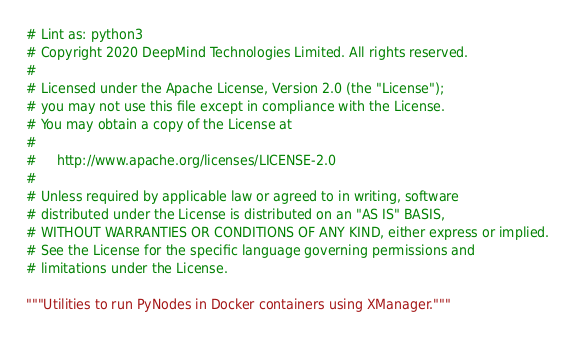<code> <loc_0><loc_0><loc_500><loc_500><_Python_># Lint as: python3
# Copyright 2020 DeepMind Technologies Limited. All rights reserved.
#
# Licensed under the Apache License, Version 2.0 (the "License");
# you may not use this file except in compliance with the License.
# You may obtain a copy of the License at
#
#     http://www.apache.org/licenses/LICENSE-2.0
#
# Unless required by applicable law or agreed to in writing, software
# distributed under the License is distributed on an "AS IS" BASIS,
# WITHOUT WARRANTIES OR CONDITIONS OF ANY KIND, either express or implied.
# See the License for the specific language governing permissions and
# limitations under the License.

"""Utilities to run PyNodes in Docker containers using XManager."""
</code> 